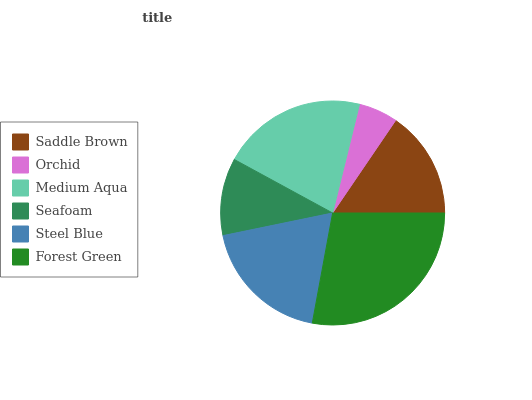Is Orchid the minimum?
Answer yes or no. Yes. Is Forest Green the maximum?
Answer yes or no. Yes. Is Medium Aqua the minimum?
Answer yes or no. No. Is Medium Aqua the maximum?
Answer yes or no. No. Is Medium Aqua greater than Orchid?
Answer yes or no. Yes. Is Orchid less than Medium Aqua?
Answer yes or no. Yes. Is Orchid greater than Medium Aqua?
Answer yes or no. No. Is Medium Aqua less than Orchid?
Answer yes or no. No. Is Steel Blue the high median?
Answer yes or no. Yes. Is Saddle Brown the low median?
Answer yes or no. Yes. Is Forest Green the high median?
Answer yes or no. No. Is Medium Aqua the low median?
Answer yes or no. No. 